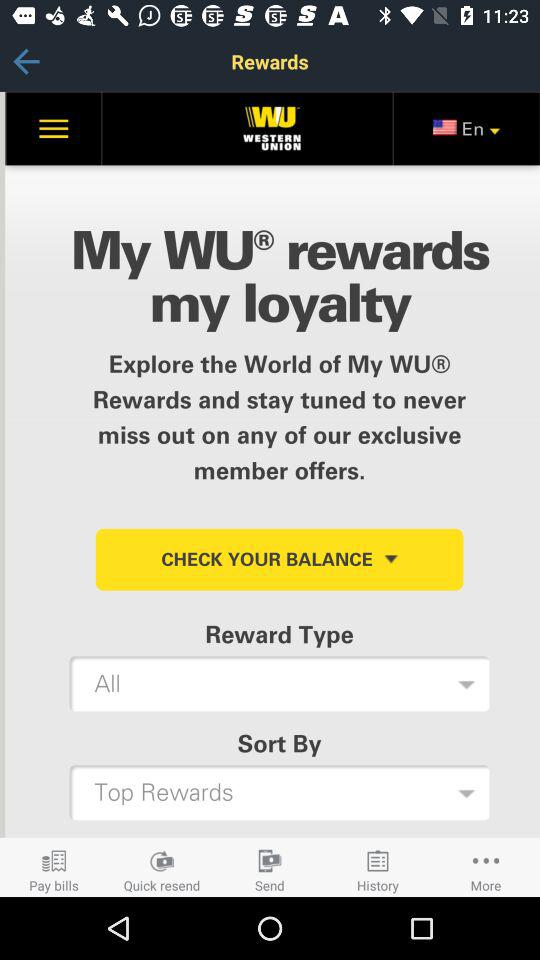Which language is selected? The selected language is English. 